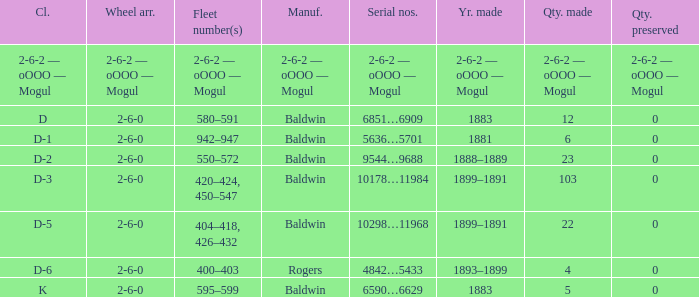What is the year made when the manufacturer is 2-6-2 — oooo — mogul? 2-6-2 — oOOO — Mogul. 